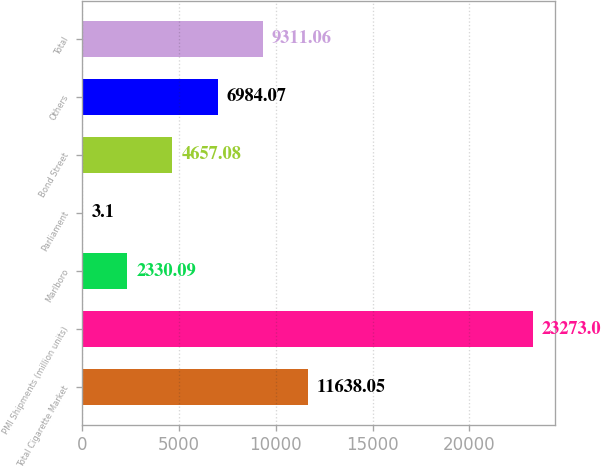Convert chart to OTSL. <chart><loc_0><loc_0><loc_500><loc_500><bar_chart><fcel>Total Cigarette Market<fcel>PMI Shipments (million units)<fcel>Marlboro<fcel>Parliament<fcel>Bond Street<fcel>Others<fcel>Total<nl><fcel>11638<fcel>23273<fcel>2330.09<fcel>3.1<fcel>4657.08<fcel>6984.07<fcel>9311.06<nl></chart> 